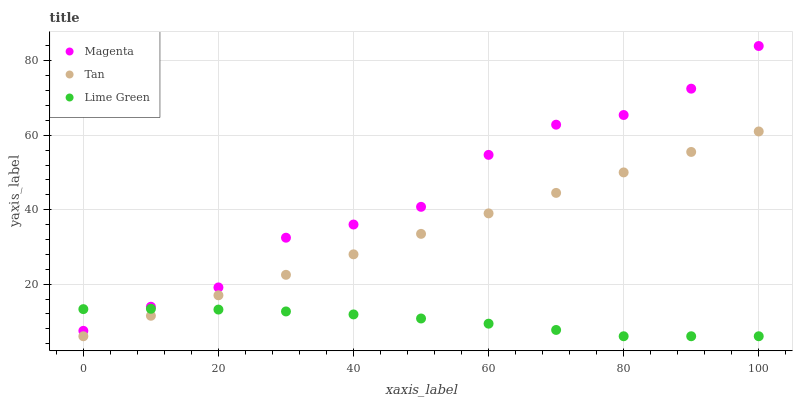Does Lime Green have the minimum area under the curve?
Answer yes or no. Yes. Does Magenta have the maximum area under the curve?
Answer yes or no. Yes. Does Tan have the minimum area under the curve?
Answer yes or no. No. Does Tan have the maximum area under the curve?
Answer yes or no. No. Is Tan the smoothest?
Answer yes or no. Yes. Is Magenta the roughest?
Answer yes or no. Yes. Is Lime Green the smoothest?
Answer yes or no. No. Is Lime Green the roughest?
Answer yes or no. No. Does Lime Green have the lowest value?
Answer yes or no. Yes. Does Magenta have the highest value?
Answer yes or no. Yes. Does Tan have the highest value?
Answer yes or no. No. Is Tan less than Magenta?
Answer yes or no. Yes. Is Magenta greater than Tan?
Answer yes or no. Yes. Does Lime Green intersect Tan?
Answer yes or no. Yes. Is Lime Green less than Tan?
Answer yes or no. No. Is Lime Green greater than Tan?
Answer yes or no. No. Does Tan intersect Magenta?
Answer yes or no. No. 